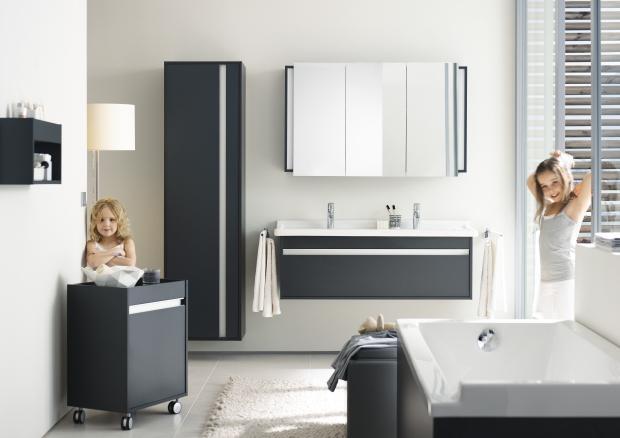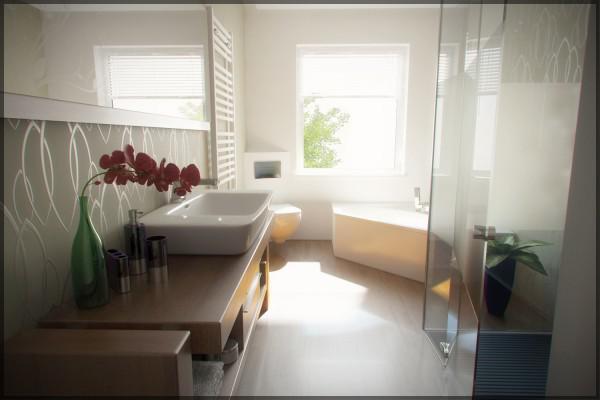The first image is the image on the left, the second image is the image on the right. For the images displayed, is the sentence "One of the bathrooms features a shower but no bathtub." factually correct? Answer yes or no. No. The first image is the image on the left, the second image is the image on the right. Considering the images on both sides, is "There is a bide as well as a toilet in a bathroom with at least one shelf behind it" valid? Answer yes or no. No. 